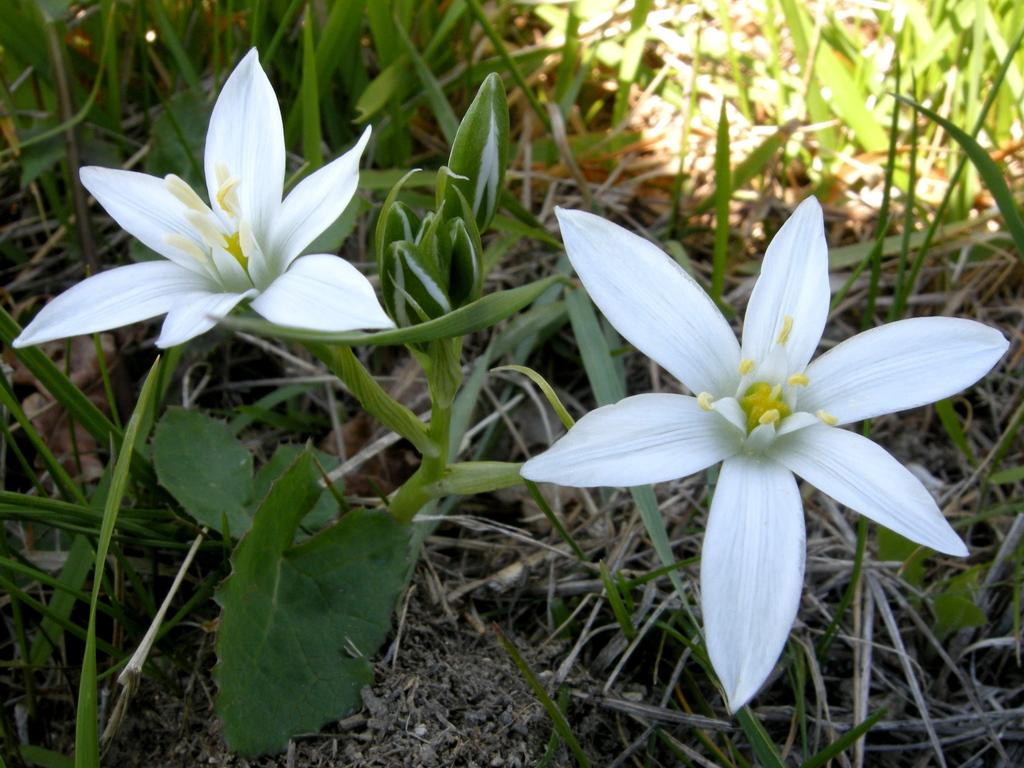What type of flowers are in the image? There are white flowers in the image. Where are the flowers located? The flowers are on a plant. What is the surrounding environment of the plant? The plant is on a grassland. How many eyes can be seen on the cabbage in the image? There is no cabbage present in the image, and therefore no eyes can be seen on it. 